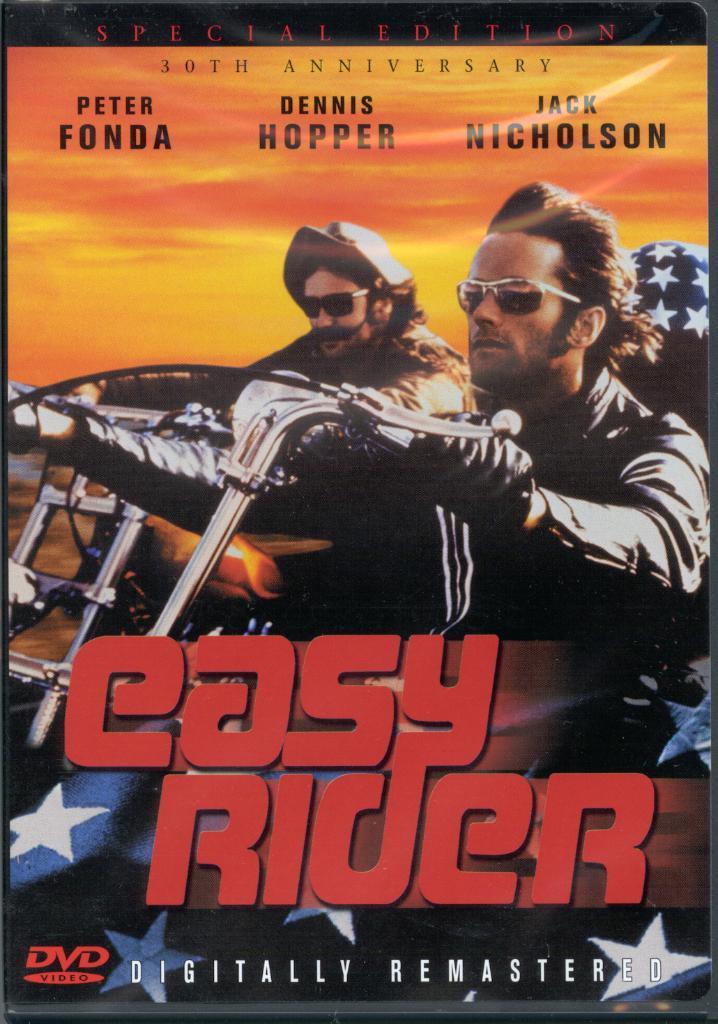Who stars in thismovie?
Provide a succinct answer. Peter fonda, dennis hopper, jack nicholson. What is the name of the movie?
Provide a succinct answer. Easy rider. 